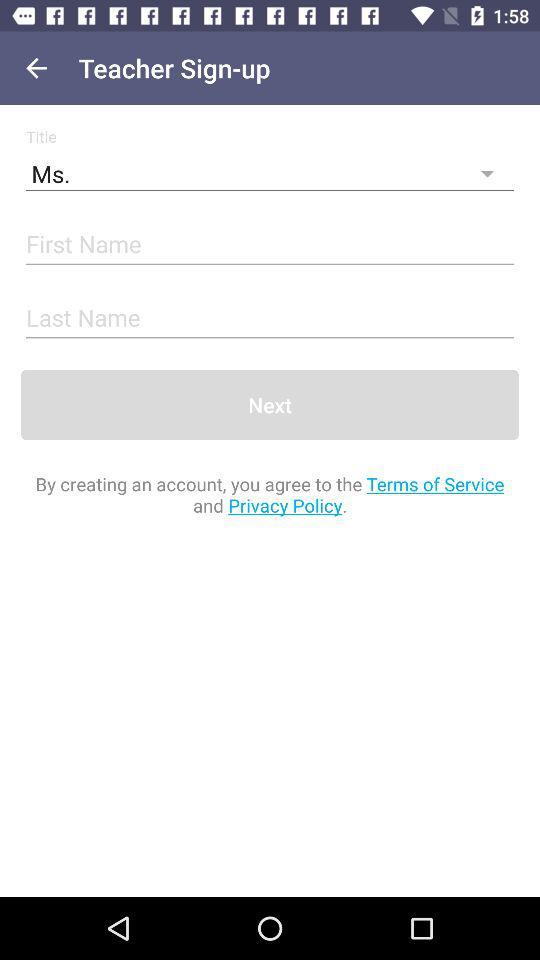Which title is selected? The selected title is "Ms.". 